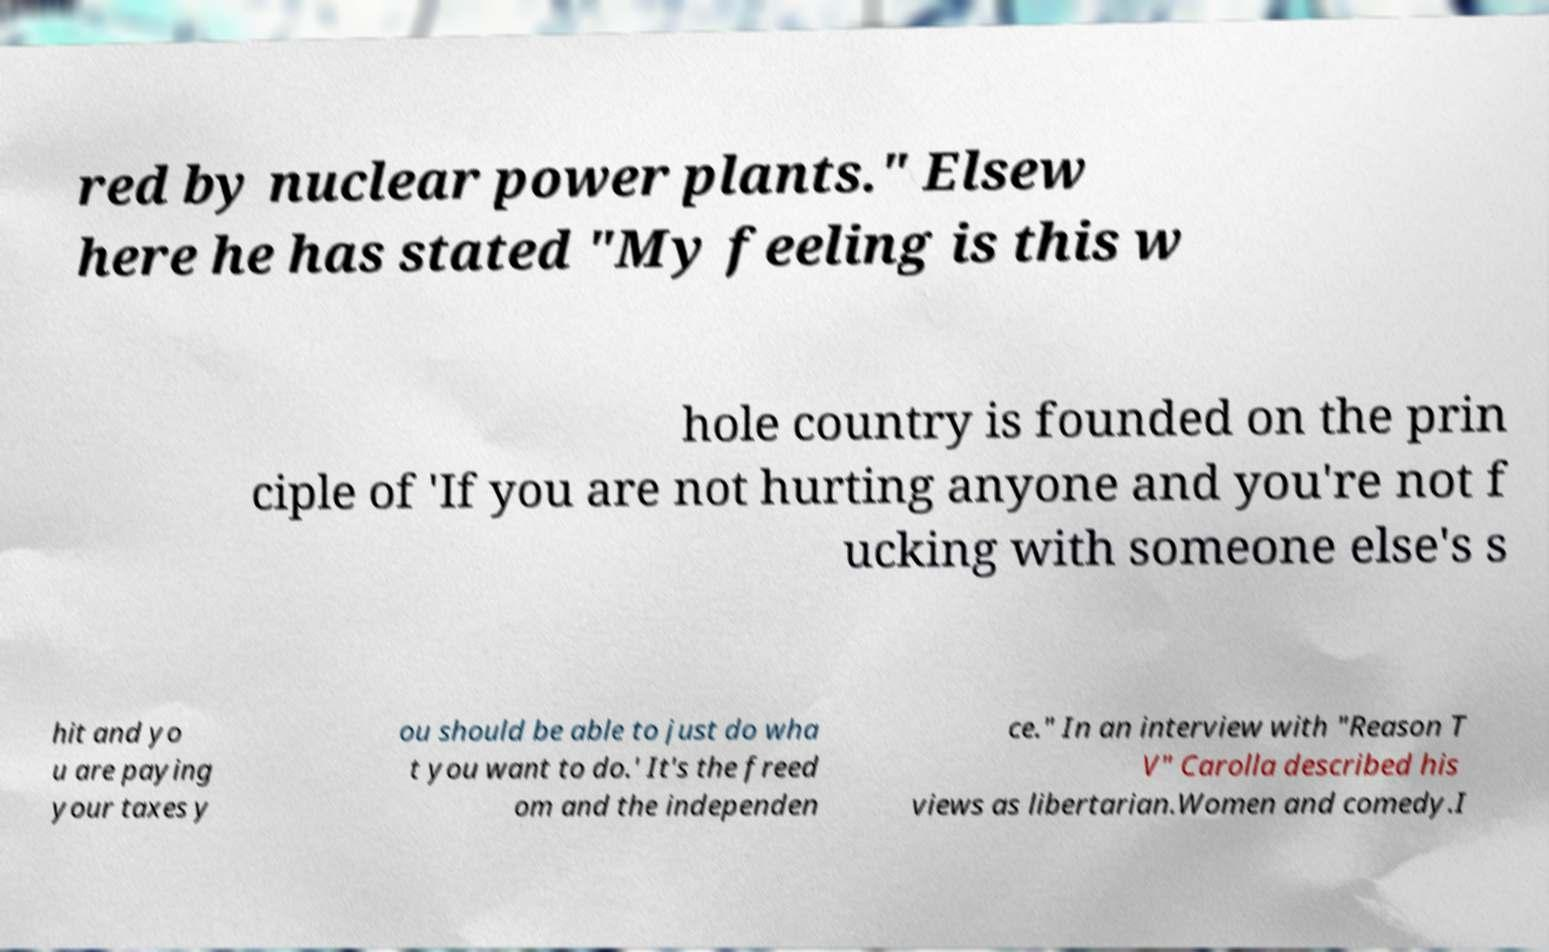Can you accurately transcribe the text from the provided image for me? red by nuclear power plants." Elsew here he has stated "My feeling is this w hole country is founded on the prin ciple of 'If you are not hurting anyone and you're not f ucking with someone else's s hit and yo u are paying your taxes y ou should be able to just do wha t you want to do.' It's the freed om and the independen ce." In an interview with "Reason T V" Carolla described his views as libertarian.Women and comedy.I 